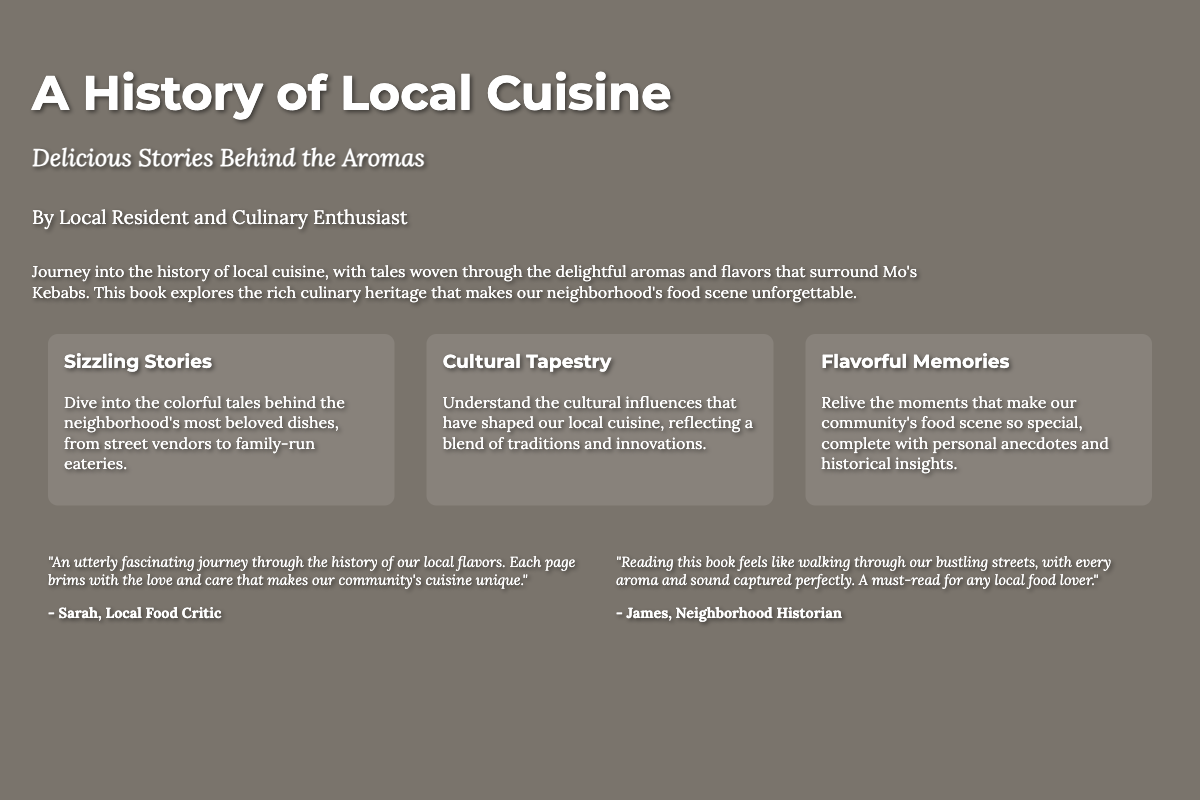What is the title of the book? The title is prominently displayed at the top of the book cover.
Answer: A History of Local Cuisine Who is the author of the book? The author is mentioned below the subtitle in the content section.
Answer: Local Resident and Culinary Enthusiast What is the subtitle of the book? The subtitle is presented right under the title.
Answer: Delicious Stories Behind the Aromas How many testimonials are featured on the cover? There are two testimonials included, each from different individuals.
Answer: 2 What is one of the elements discussed in the book? The elements section lists various aspects of local cuisine.
Answer: Sizzling Stories What does the author aim to explore in the book? The description highlights the author's intent regarding local cuisine history.
Answer: Culinary heritage Who provided a testimonial that emphasizes aroma and sound? The name of the person highlighting the sensory experience is stated in the testimonial.
Answer: James What kind of memories are relived in the book? The description mentions certain types of moments that the book encapsulates.
Answer: Flavorful Memories 